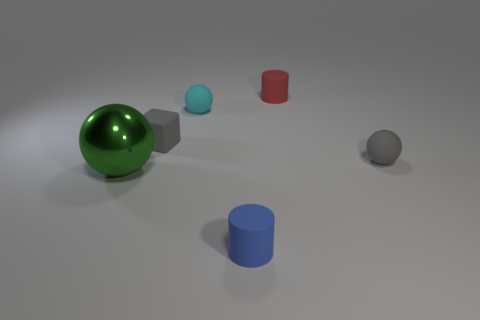Add 3 big red metal things. How many objects exist? 9 Subtract all brown cylinders. Subtract all brown balls. How many cylinders are left? 2 Subtract all blocks. How many objects are left? 5 Subtract all gray matte balls. Subtract all large green metal things. How many objects are left? 4 Add 3 cyan matte spheres. How many cyan matte spheres are left? 4 Add 4 large green metal balls. How many large green metal balls exist? 5 Subtract 0 purple blocks. How many objects are left? 6 